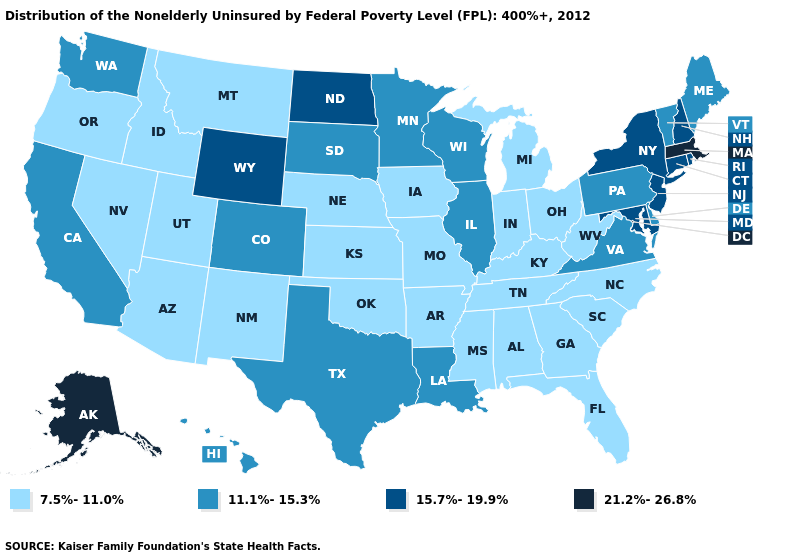What is the lowest value in states that border Michigan?
Keep it brief. 7.5%-11.0%. Which states have the lowest value in the USA?
Keep it brief. Alabama, Arizona, Arkansas, Florida, Georgia, Idaho, Indiana, Iowa, Kansas, Kentucky, Michigan, Mississippi, Missouri, Montana, Nebraska, Nevada, New Mexico, North Carolina, Ohio, Oklahoma, Oregon, South Carolina, Tennessee, Utah, West Virginia. What is the value of Indiana?
Concise answer only. 7.5%-11.0%. Name the states that have a value in the range 7.5%-11.0%?
Be succinct. Alabama, Arizona, Arkansas, Florida, Georgia, Idaho, Indiana, Iowa, Kansas, Kentucky, Michigan, Mississippi, Missouri, Montana, Nebraska, Nevada, New Mexico, North Carolina, Ohio, Oklahoma, Oregon, South Carolina, Tennessee, Utah, West Virginia. Name the states that have a value in the range 7.5%-11.0%?
Answer briefly. Alabama, Arizona, Arkansas, Florida, Georgia, Idaho, Indiana, Iowa, Kansas, Kentucky, Michigan, Mississippi, Missouri, Montana, Nebraska, Nevada, New Mexico, North Carolina, Ohio, Oklahoma, Oregon, South Carolina, Tennessee, Utah, West Virginia. Does Alaska have the highest value in the West?
Keep it brief. Yes. Does Minnesota have the highest value in the MidWest?
Give a very brief answer. No. Name the states that have a value in the range 21.2%-26.8%?
Be succinct. Alaska, Massachusetts. Which states hav the highest value in the South?
Keep it brief. Maryland. Does Louisiana have a lower value than Illinois?
Concise answer only. No. Among the states that border Arkansas , which have the lowest value?
Give a very brief answer. Mississippi, Missouri, Oklahoma, Tennessee. Does Massachusetts have the highest value in the Northeast?
Keep it brief. Yes. What is the lowest value in the Northeast?
Quick response, please. 11.1%-15.3%. Which states have the lowest value in the MidWest?
Give a very brief answer. Indiana, Iowa, Kansas, Michigan, Missouri, Nebraska, Ohio. Name the states that have a value in the range 15.7%-19.9%?
Keep it brief. Connecticut, Maryland, New Hampshire, New Jersey, New York, North Dakota, Rhode Island, Wyoming. 